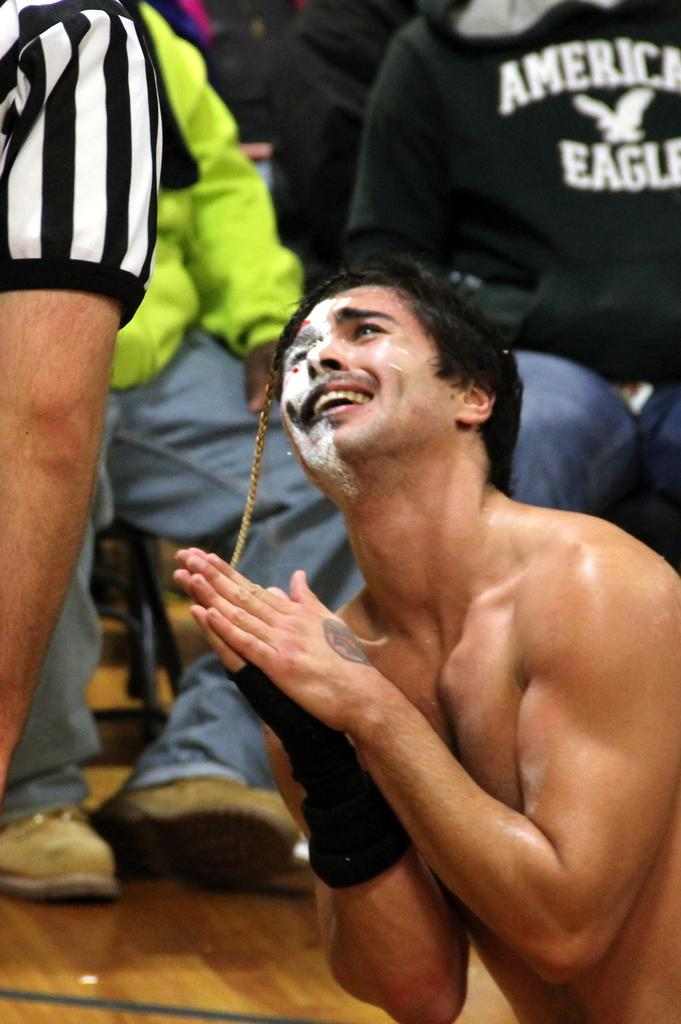<image>
Provide a brief description of the given image. A man stands in front of someone wearing an American Eagle sweatshirt. 